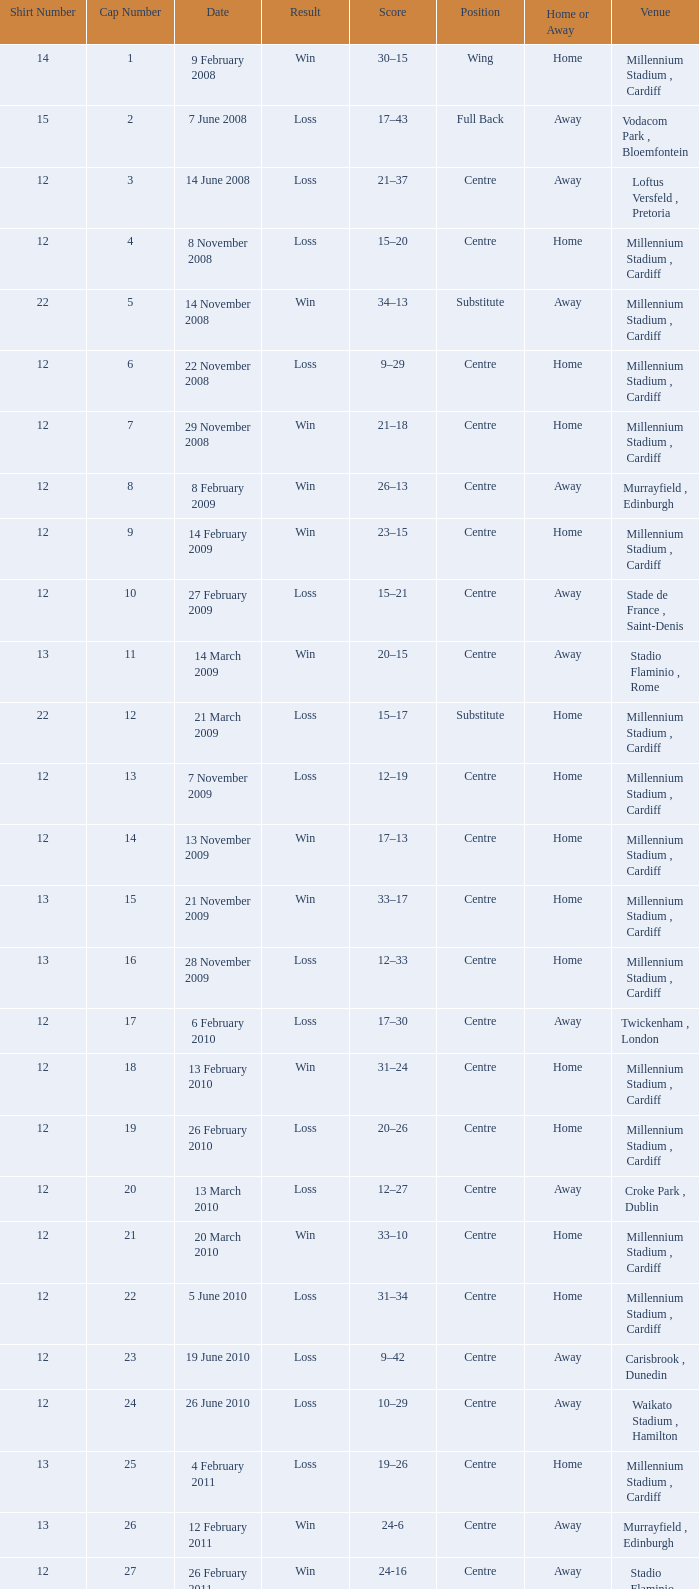What's the largest shirt number when the cap number is 5? 22.0. 